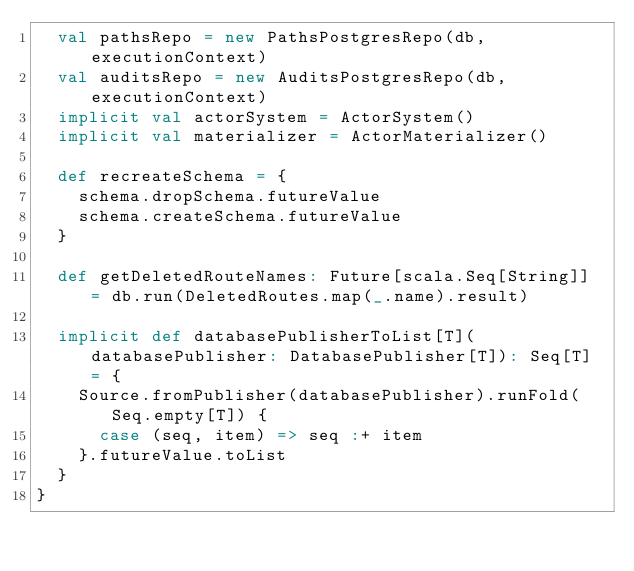Convert code to text. <code><loc_0><loc_0><loc_500><loc_500><_Scala_>  val pathsRepo = new PathsPostgresRepo(db, executionContext)
  val auditsRepo = new AuditsPostgresRepo(db, executionContext)
  implicit val actorSystem = ActorSystem()
  implicit val materializer = ActorMaterializer()

  def recreateSchema = {
    schema.dropSchema.futureValue
    schema.createSchema.futureValue
  }

  def getDeletedRouteNames: Future[scala.Seq[String]] = db.run(DeletedRoutes.map(_.name).result)

  implicit def databasePublisherToList[T](databasePublisher: DatabasePublisher[T]): Seq[T] = {
    Source.fromPublisher(databasePublisher).runFold(Seq.empty[T]) {
      case (seq, item) => seq :+ item
    }.futureValue.toList
  }
}
</code> 